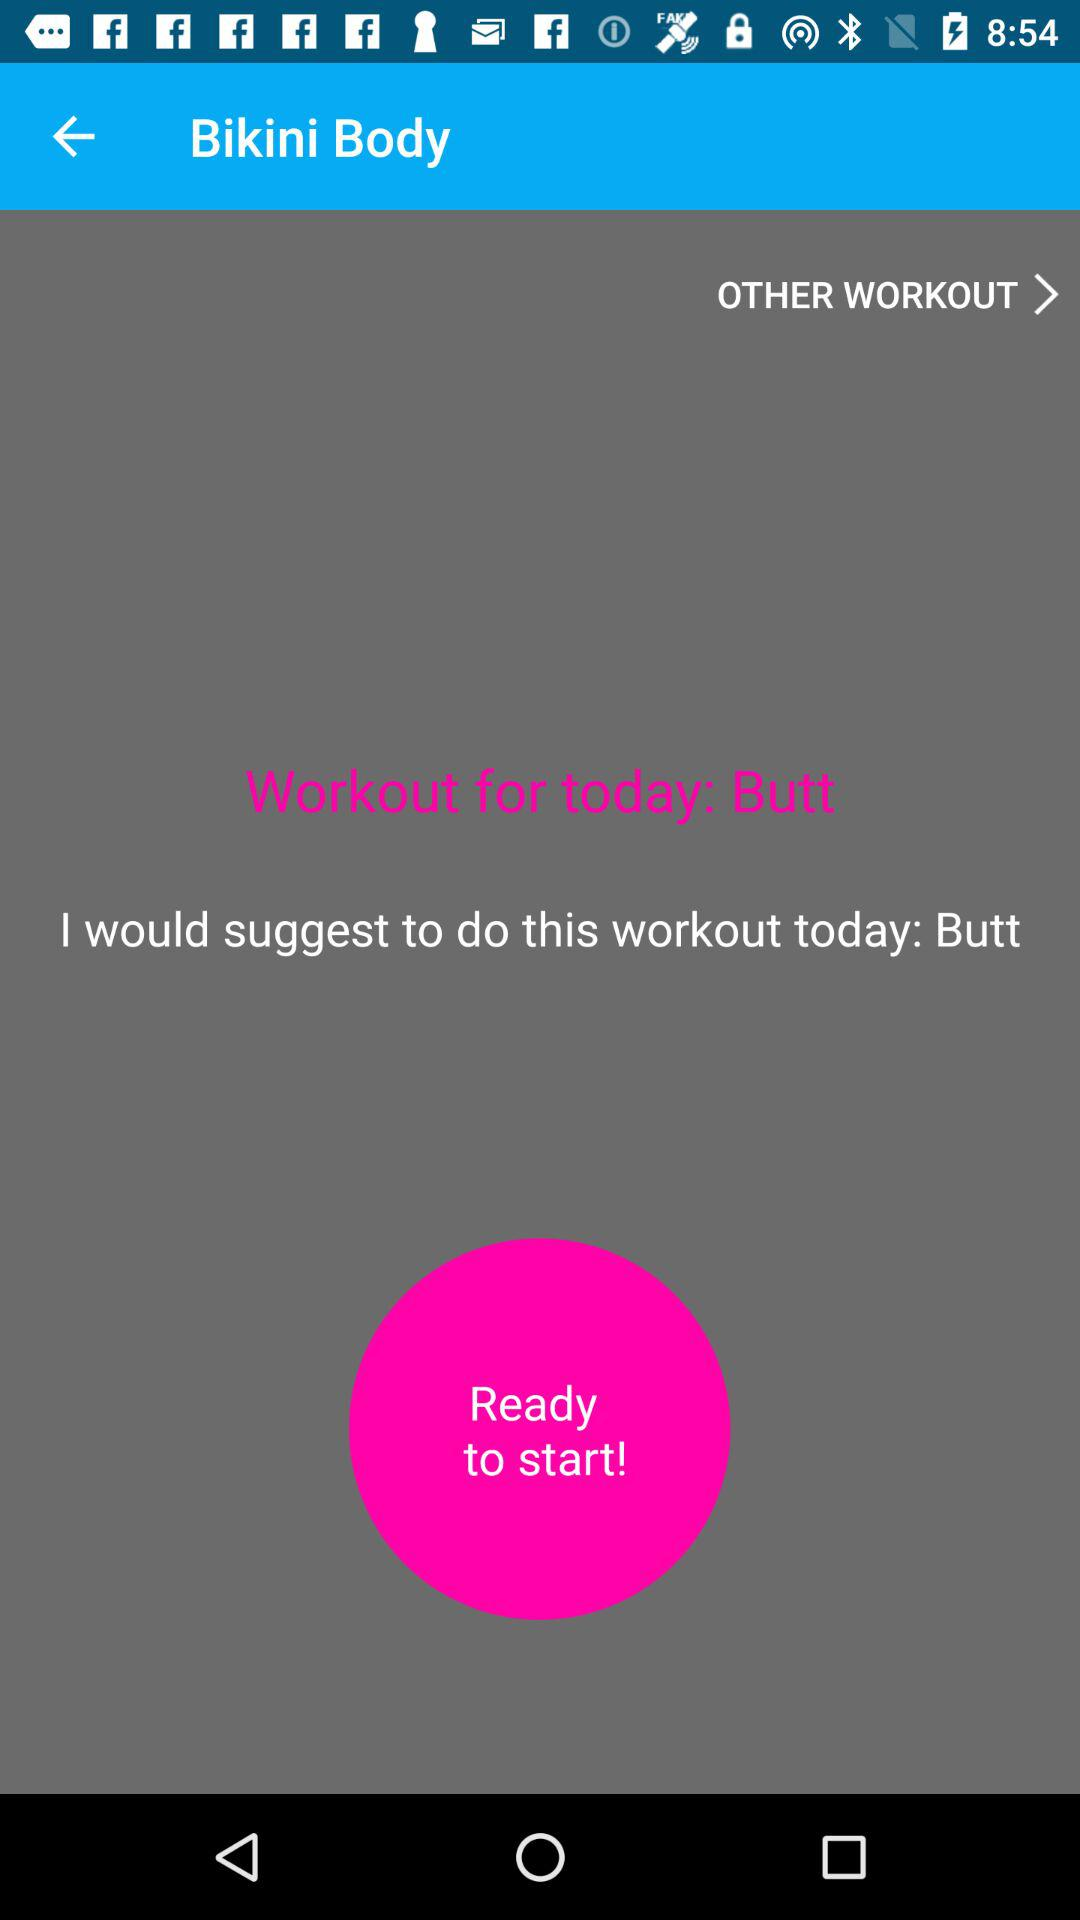What is the application name?
When the provided information is insufficient, respond with <no answer>. <no answer> 